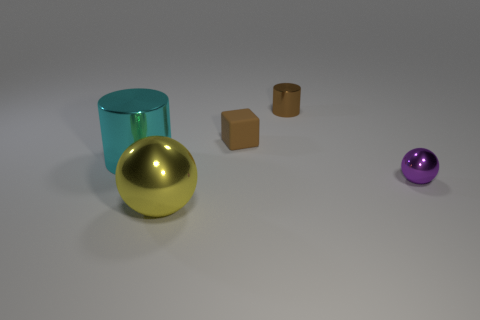Add 1 big green cylinders. How many objects exist? 6 Subtract all balls. How many objects are left? 3 Add 3 brown cylinders. How many brown cylinders exist? 4 Subtract 0 gray balls. How many objects are left? 5 Subtract all blue matte objects. Subtract all large shiny cylinders. How many objects are left? 4 Add 4 tiny cylinders. How many tiny cylinders are left? 5 